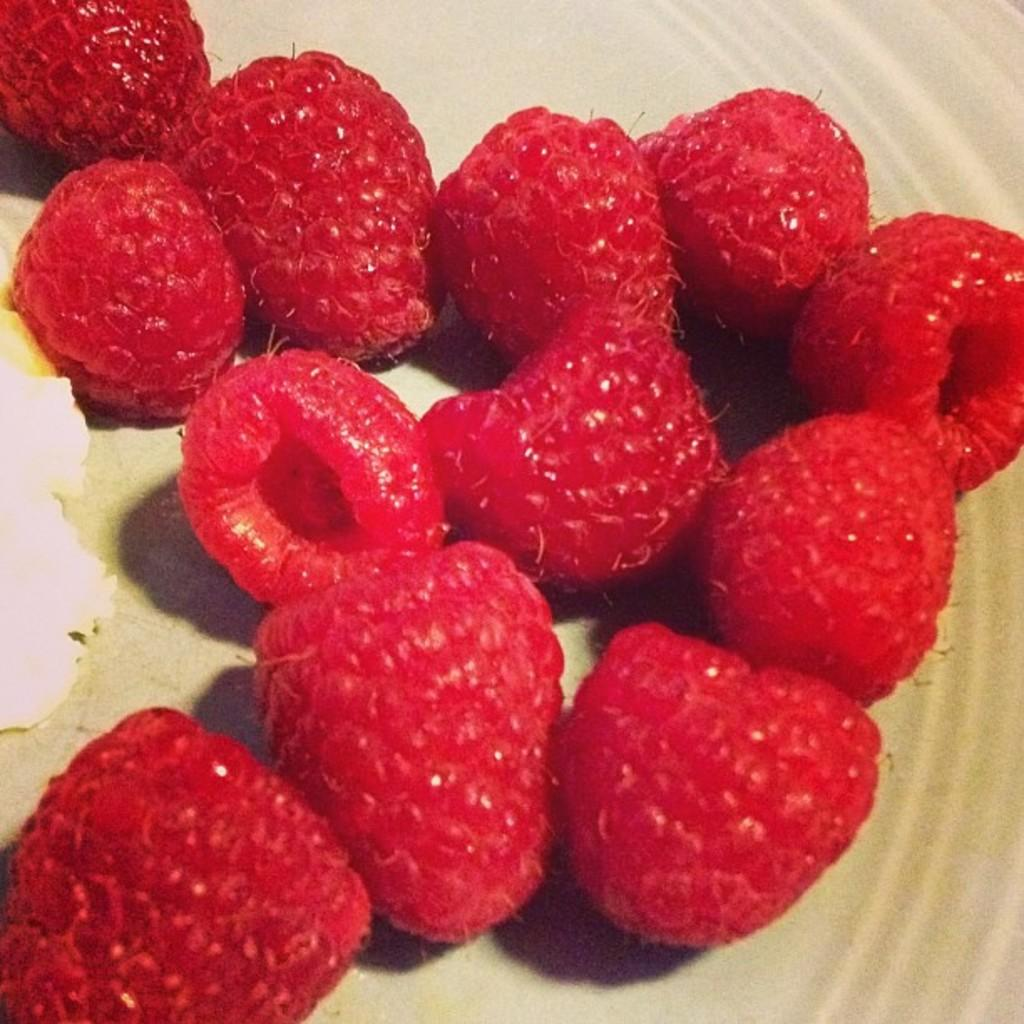What is on the plate that is visible in the image? The plate contains strawberries. Are there any other items on the plate besides strawberries? Yes, there is other food on the plate. What type of hammer is being used to create the cloud formation in the image? There is no hammer or cloud formation present in the image; it only features a plate with strawberries and other food. 